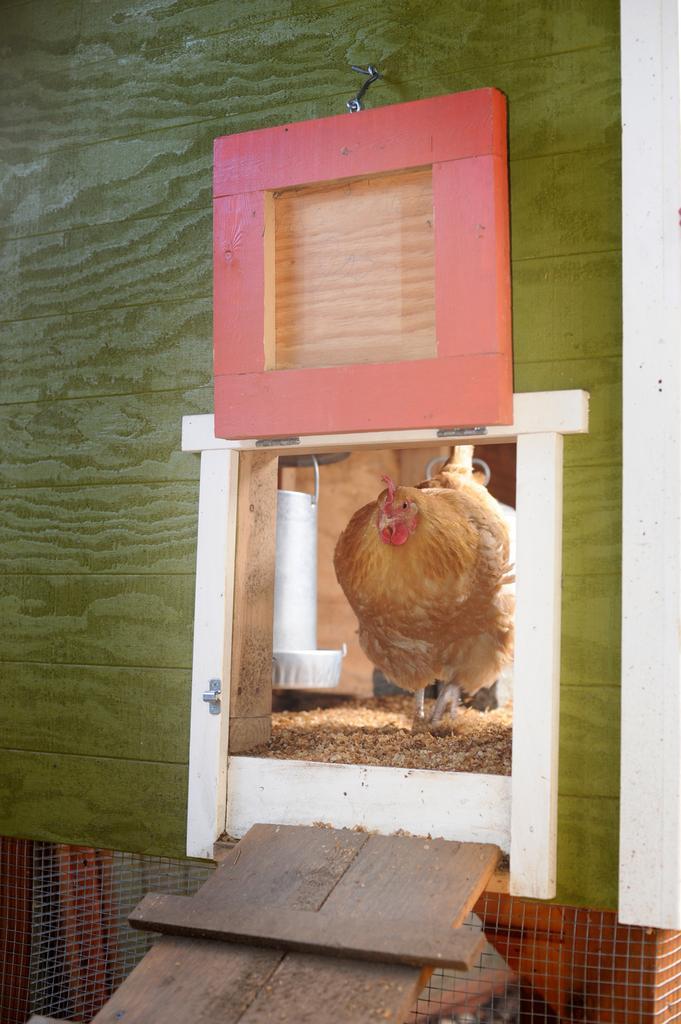How would you summarize this image in a sentence or two? In this image I can see the hen which is in brown color. It is inside the cage. The cage is in white, green and red color. In-front of the cage there is a brown color wooden surface and net. 